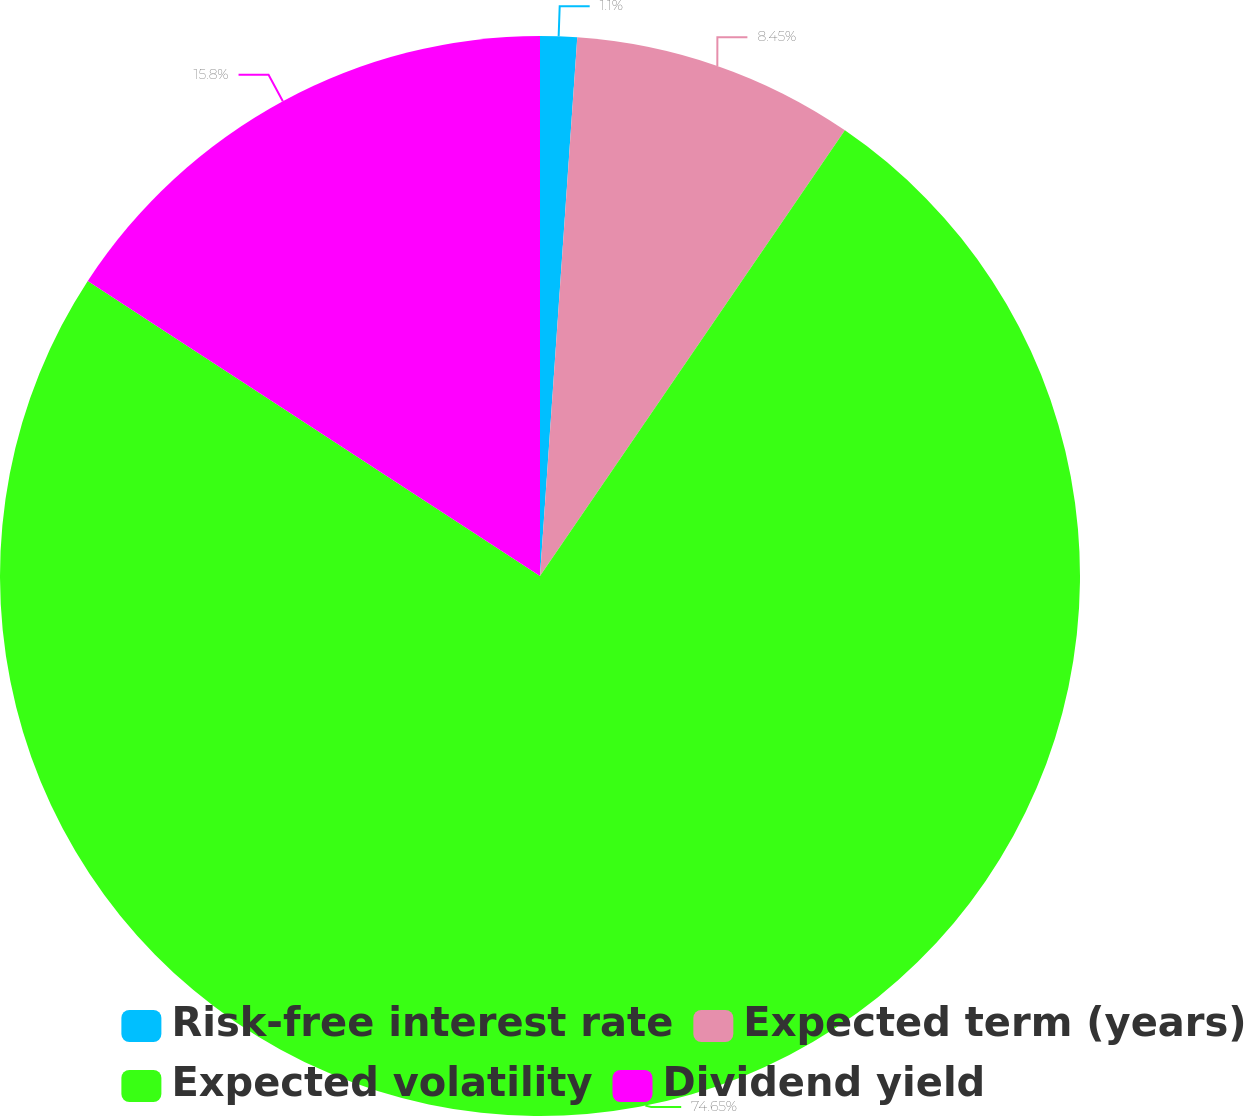Convert chart. <chart><loc_0><loc_0><loc_500><loc_500><pie_chart><fcel>Risk-free interest rate<fcel>Expected term (years)<fcel>Expected volatility<fcel>Dividend yield<nl><fcel>1.1%<fcel>8.45%<fcel>74.65%<fcel>15.8%<nl></chart> 